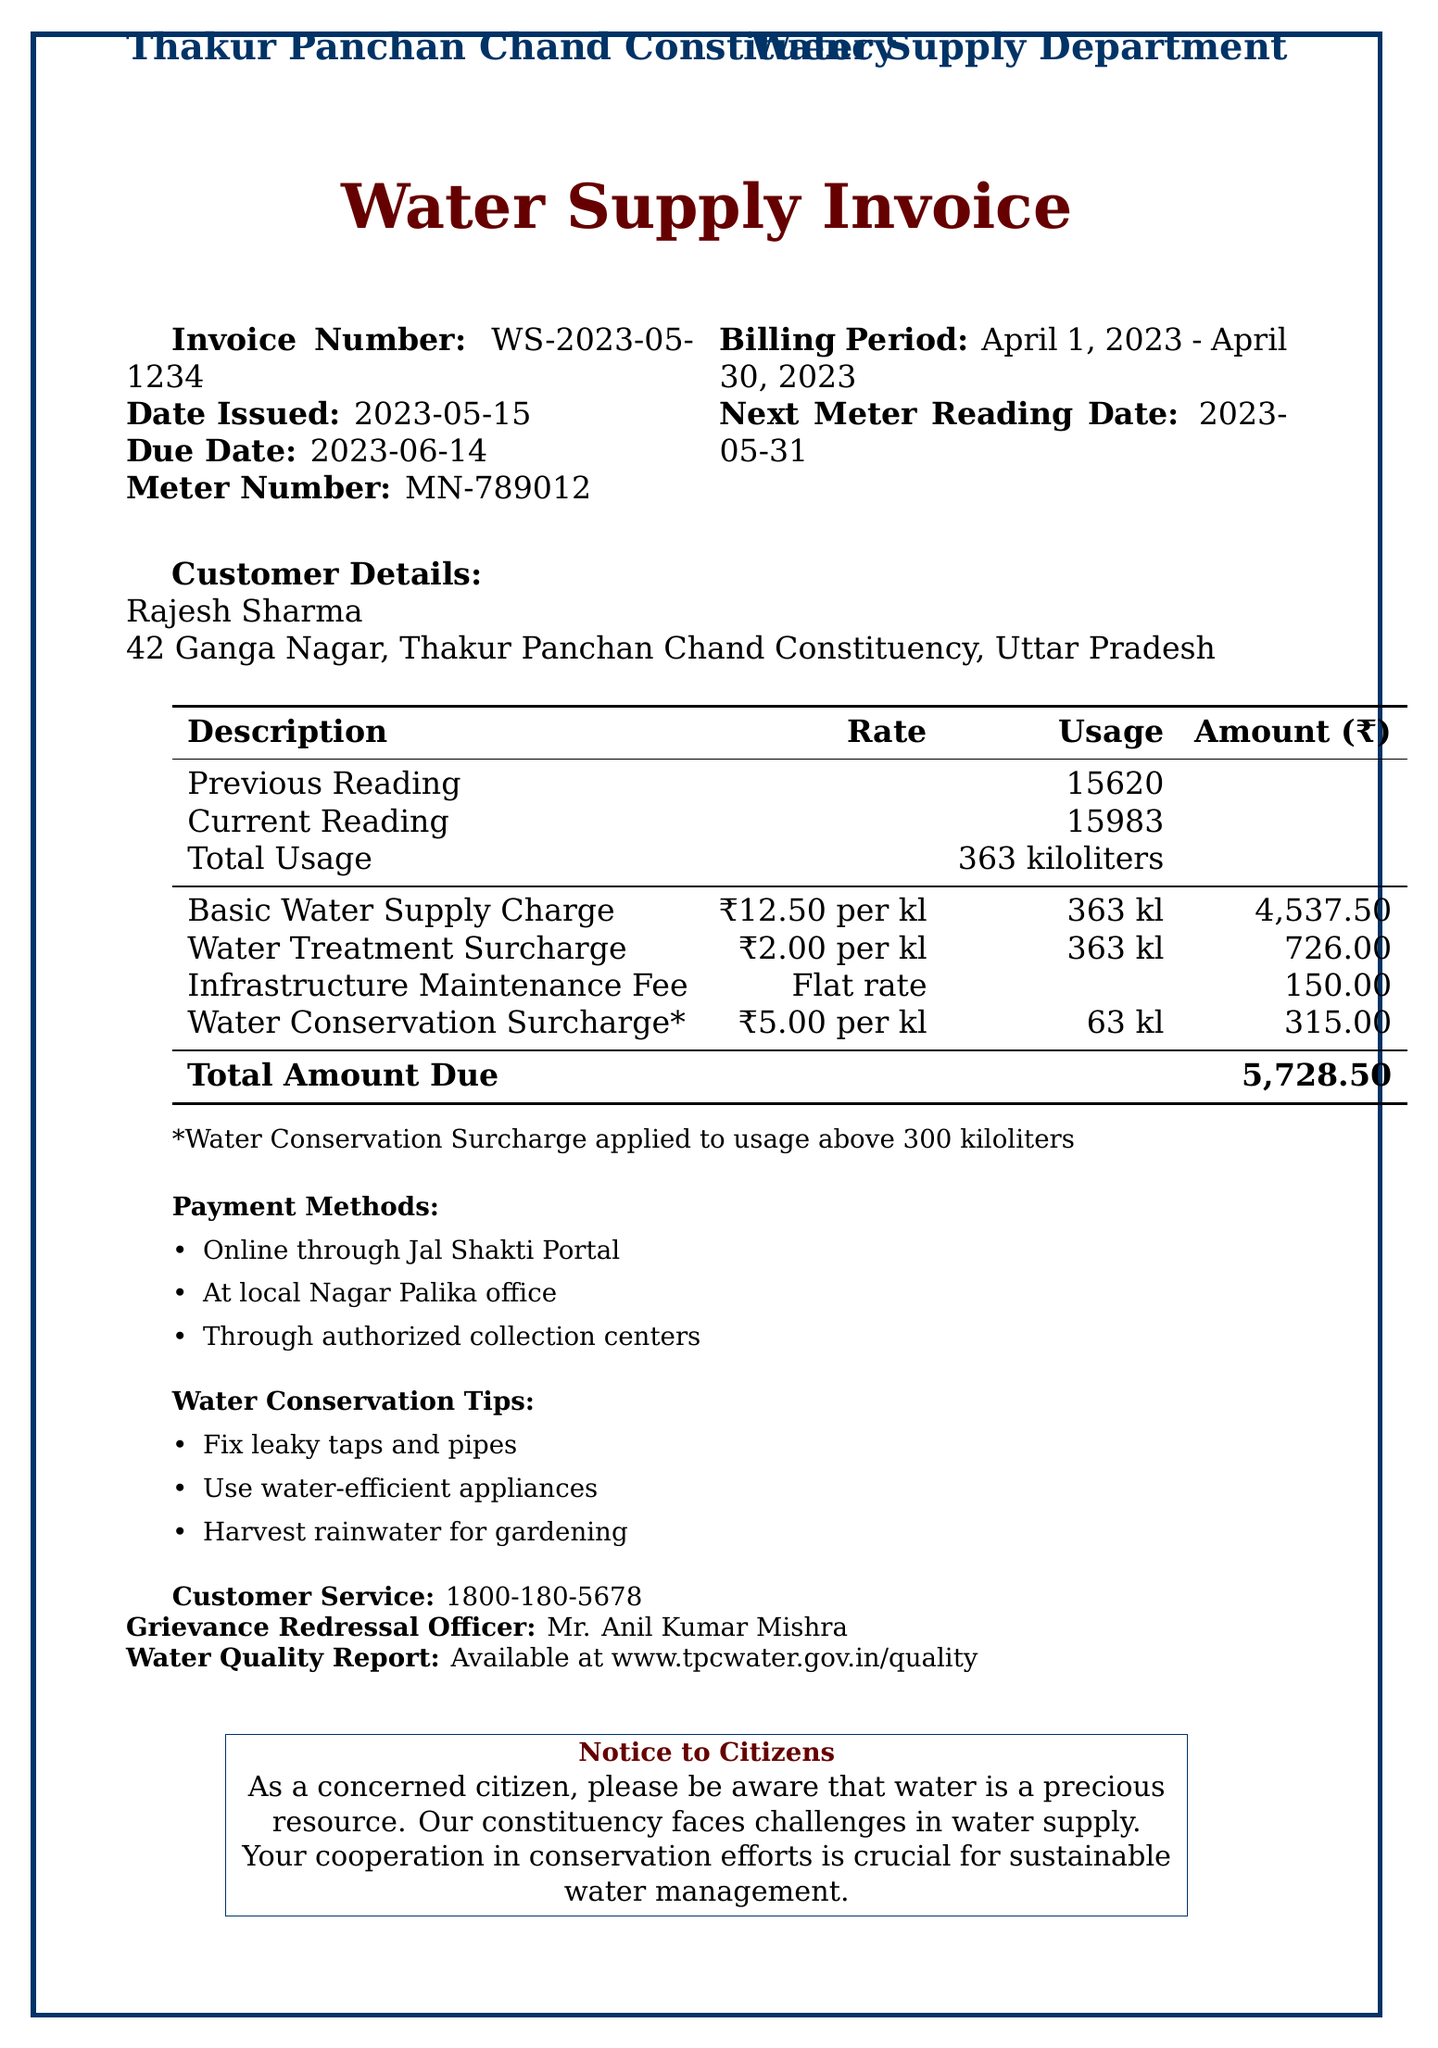What is the invoice number? The invoice number is listed at the top of the invoice document.
Answer: WS-2023-05-1234 Who is the customer? The customer name is provided in the customer details section of the document.
Answer: Rajesh Sharma What is the total usage in kiloliters? The total usage is stated in the billing details of the invoice.
Answer: 363 kiloliters What is the due date? The due date is mentioned clearly in the invoice issue details.
Answer: 2023-06-14 How much is the Water Conservation Surcharge? The Water Conservation Surcharge amount is found under the charges section.
Answer: 315.00 What is the flat rate for the Infrastructure Maintenance Fee? The Infrastructure Maintenance Fee is provided as a flat fee in the charges section.
Answer: 150.00 How much is the total amount due? The total amount due is highlighted at the bottom of the invoice.
Answer: 5728.50 What is the next meter reading date? The next meter reading date is listed towards the top of the document.
Answer: 2023-05-31 What tips are provided for water conservation? The tips are listed towards the end of the invoice in the conservation tips section.
Answer: Fix leaky taps and pipes; Use water-efficient appliances; Harvest rainwater for gardening 